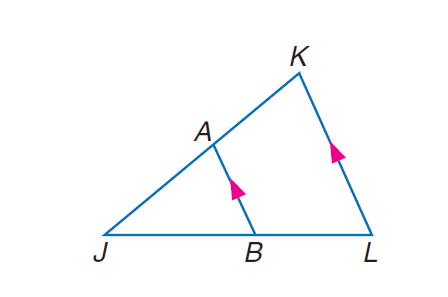Question: If J L = 27, B L = 9, and J K = 18, find J A.
Choices:
A. 9
B. 12
C. 13.5
D. 18
Answer with the letter. Answer: B 